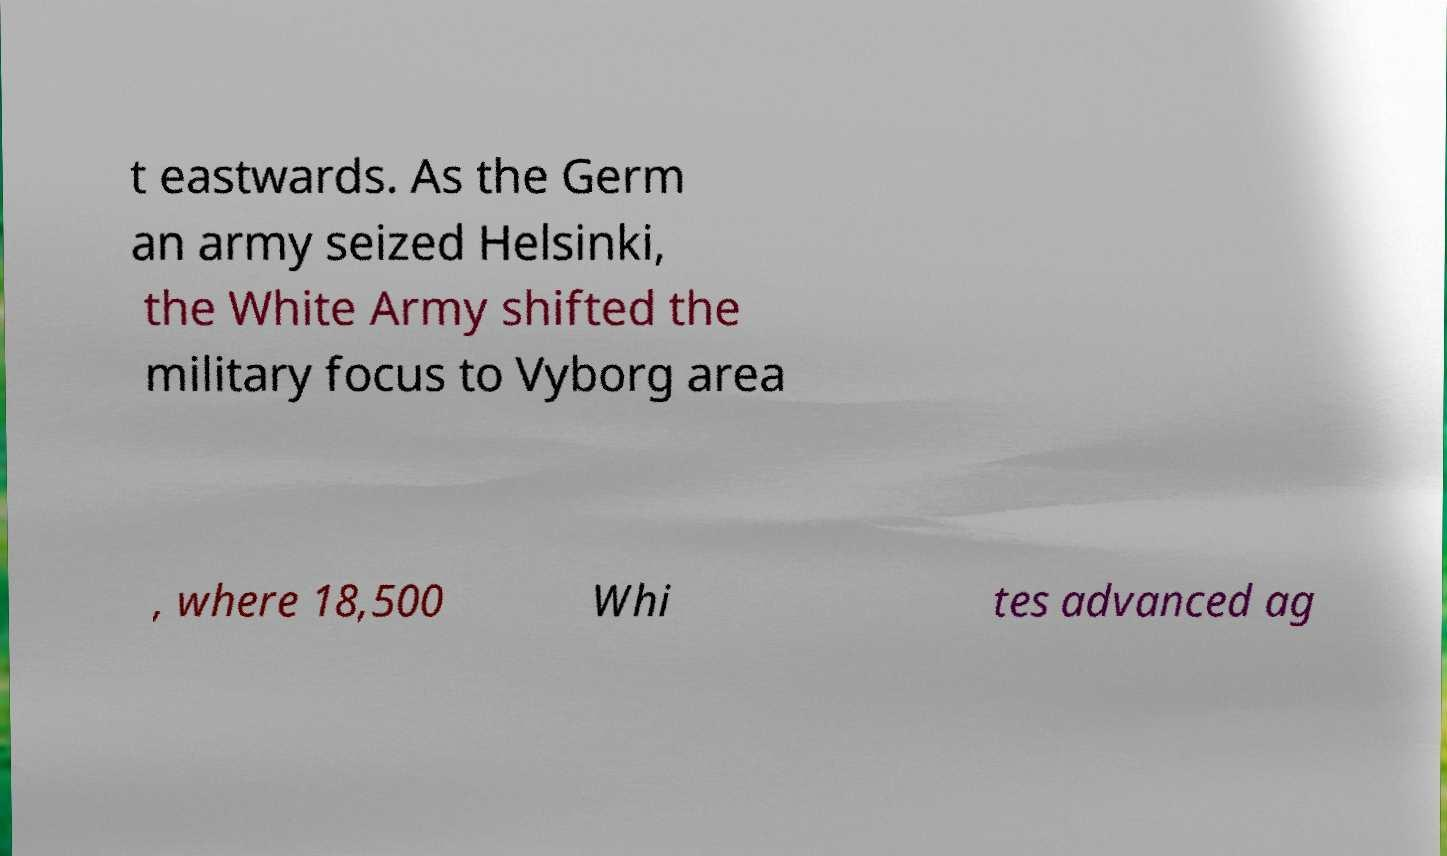Please identify and transcribe the text found in this image. t eastwards. As the Germ an army seized Helsinki, the White Army shifted the military focus to Vyborg area , where 18,500 Whi tes advanced ag 